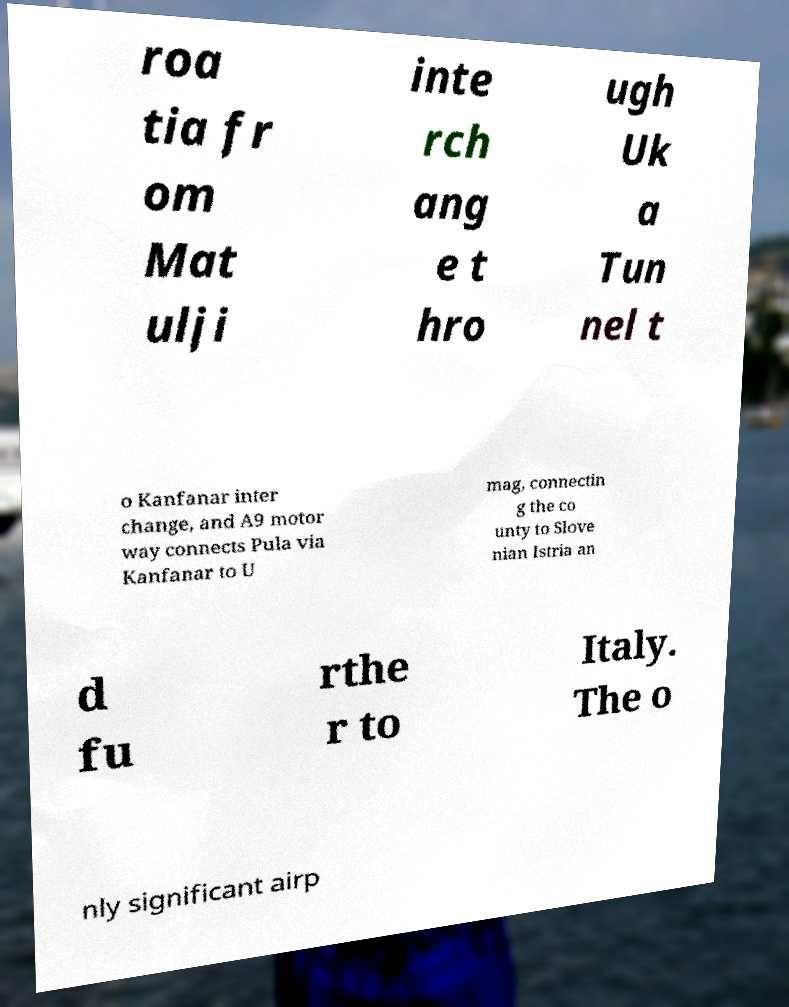Can you read and provide the text displayed in the image?This photo seems to have some interesting text. Can you extract and type it out for me? roa tia fr om Mat ulji inte rch ang e t hro ugh Uk a Tun nel t o Kanfanar inter change, and A9 motor way connects Pula via Kanfanar to U mag, connectin g the co unty to Slove nian Istria an d fu rthe r to Italy. The o nly significant airp 